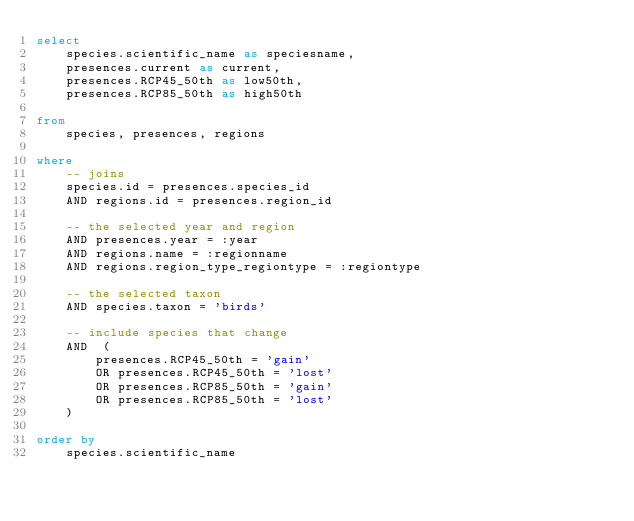Convert code to text. <code><loc_0><loc_0><loc_500><loc_500><_SQL_>select
    species.scientific_name as speciesname,
    presences.current as current,
    presences.RCP45_50th as low50th,
    presences.RCP85_50th as high50th

from
    species, presences, regions

where
    -- joins
    species.id = presences.species_id
    AND regions.id = presences.region_id

    -- the selected year and region
    AND presences.year = :year
    AND regions.name = :regionname
    AND regions.region_type_regiontype = :regiontype

    -- the selected taxon
    AND species.taxon = 'birds'

    -- include species that change
    AND  (
        presences.RCP45_50th = 'gain'
        OR presences.RCP45_50th = 'lost'
        OR presences.RCP85_50th = 'gain'
        OR presences.RCP85_50th = 'lost'
    )

order by
    species.scientific_name</code> 